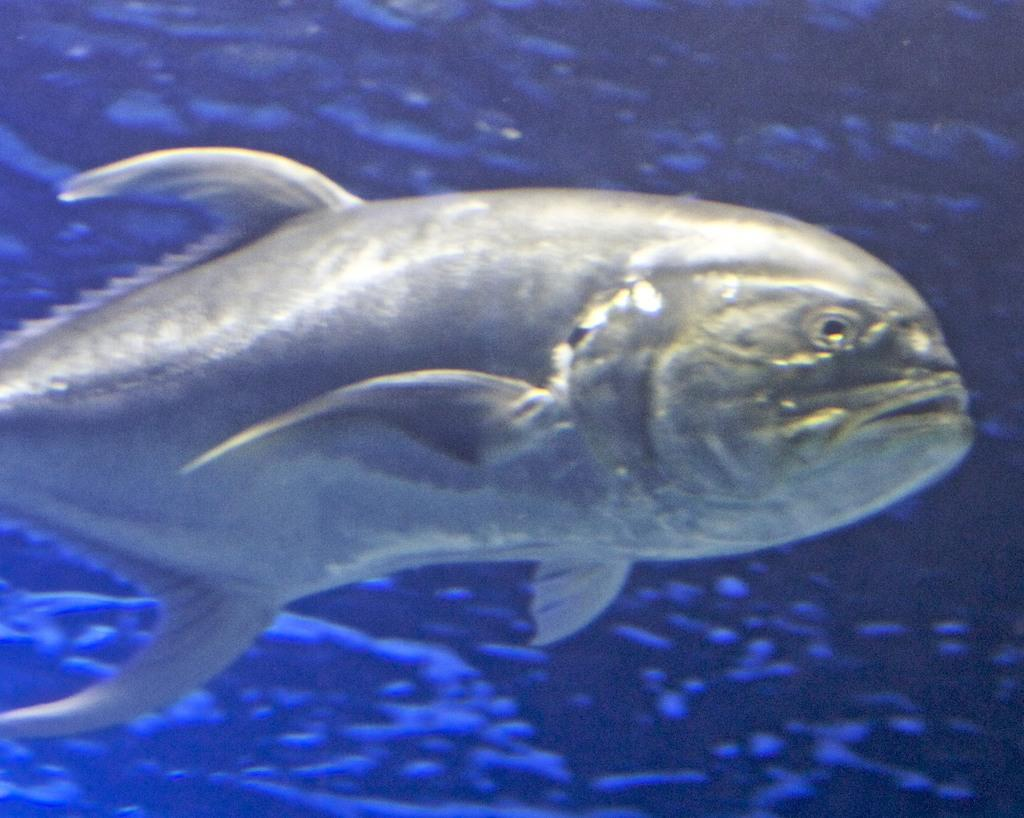What is happening in the water in the image? There are fish swimming in the water. What color is the background of the image? The background of the image is blue. Can you see a locket hanging from the fang of a boot in the image? There is no locket, fang, or boot present in the image. 